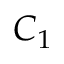<formula> <loc_0><loc_0><loc_500><loc_500>C _ { 1 }</formula> 